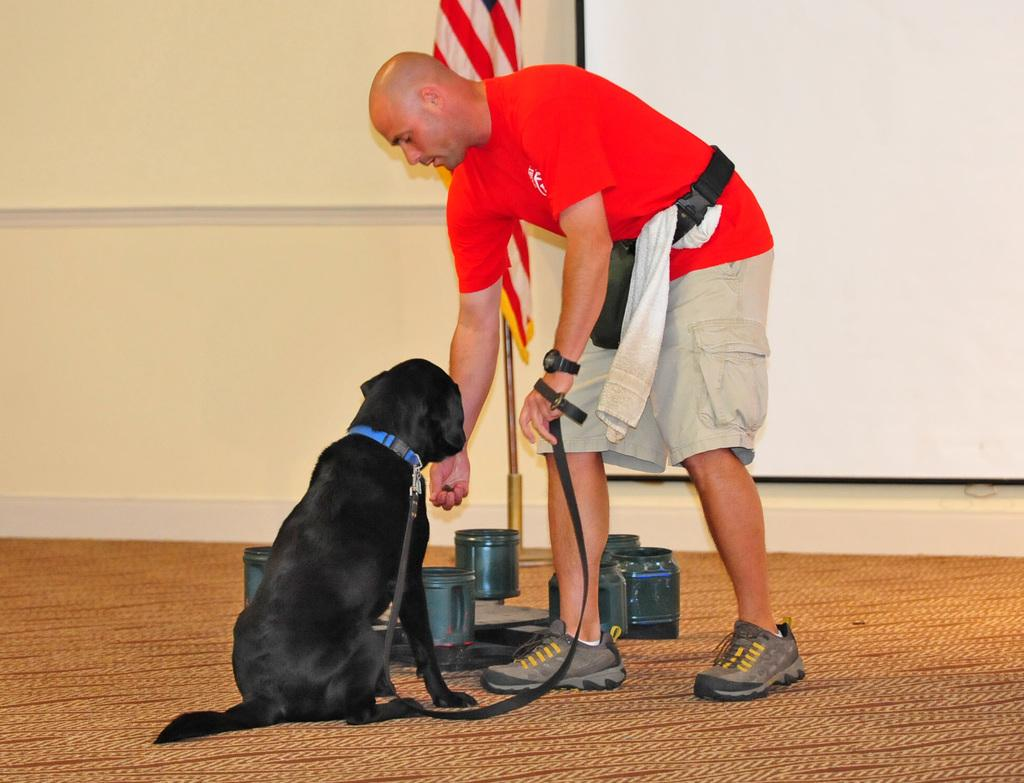Who is present in the image? There is a man in the image. What is the man holding in the image? The man is holding a dog. What objects can be seen in the image besides the man and the dog? There are jars, a flag, and a projector screen in the image. What type of cakes are being discussed by the man and the dog in the image? There is no discussion or cakes present in the image; it features a man holding a dog and other objects. Can you see a train in the image? There is no train present in the image. 